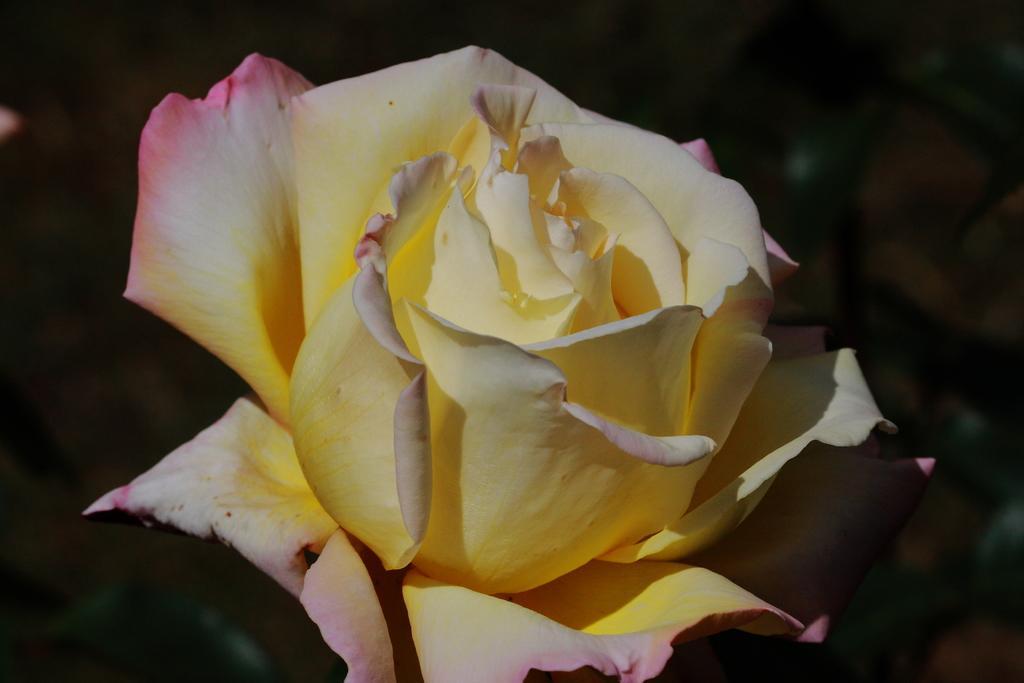In one or two sentences, can you explain what this image depicts? In this image, I can see a rose flower and plants. This picture is taken, maybe during night. 